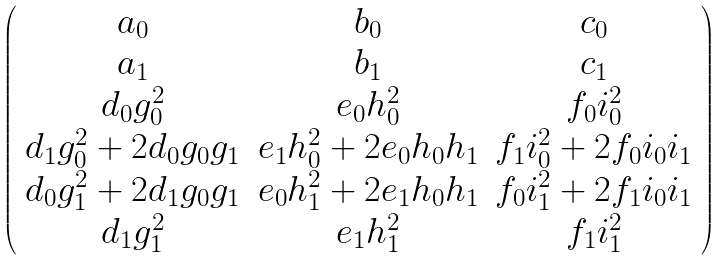Convert formula to latex. <formula><loc_0><loc_0><loc_500><loc_500>\left ( \begin{array} { c c c c } a _ { 0 } & b _ { 0 } & c _ { 0 } \\ a _ { 1 } & b _ { 1 } & c _ { 1 } \\ d _ { 0 } g _ { 0 } ^ { 2 } & e _ { 0 } h _ { 0 } ^ { 2 } & f _ { 0 } i _ { 0 } ^ { 2 } \\ d _ { 1 } g _ { 0 } ^ { 2 } + 2 d _ { 0 } g _ { 0 } g _ { 1 } & e _ { 1 } h _ { 0 } ^ { 2 } + 2 e _ { 0 } h _ { 0 } h _ { 1 } & f _ { 1 } i _ { 0 } ^ { 2 } + 2 f _ { 0 } i _ { 0 } i _ { 1 } \\ d _ { 0 } g _ { 1 } ^ { 2 } + 2 d _ { 1 } g _ { 0 } g _ { 1 } & e _ { 0 } h _ { 1 } ^ { 2 } + 2 e _ { 1 } h _ { 0 } h _ { 1 } & f _ { 0 } i _ { 1 } ^ { 2 } + 2 f _ { 1 } i _ { 0 } i _ { 1 } \\ d _ { 1 } g _ { 1 } ^ { 2 } & e _ { 1 } h _ { 1 } ^ { 2 } & f _ { 1 } i _ { 1 } ^ { 2 } \end{array} \right )</formula> 